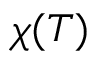Convert formula to latex. <formula><loc_0><loc_0><loc_500><loc_500>\chi ( T )</formula> 